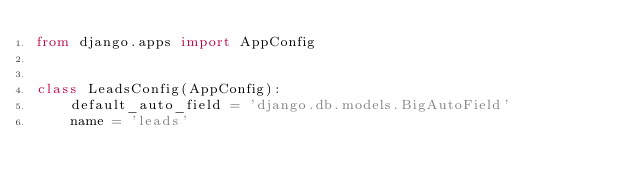Convert code to text. <code><loc_0><loc_0><loc_500><loc_500><_Python_>from django.apps import AppConfig


class LeadsConfig(AppConfig):
    default_auto_field = 'django.db.models.BigAutoField'
    name = 'leads'
</code> 